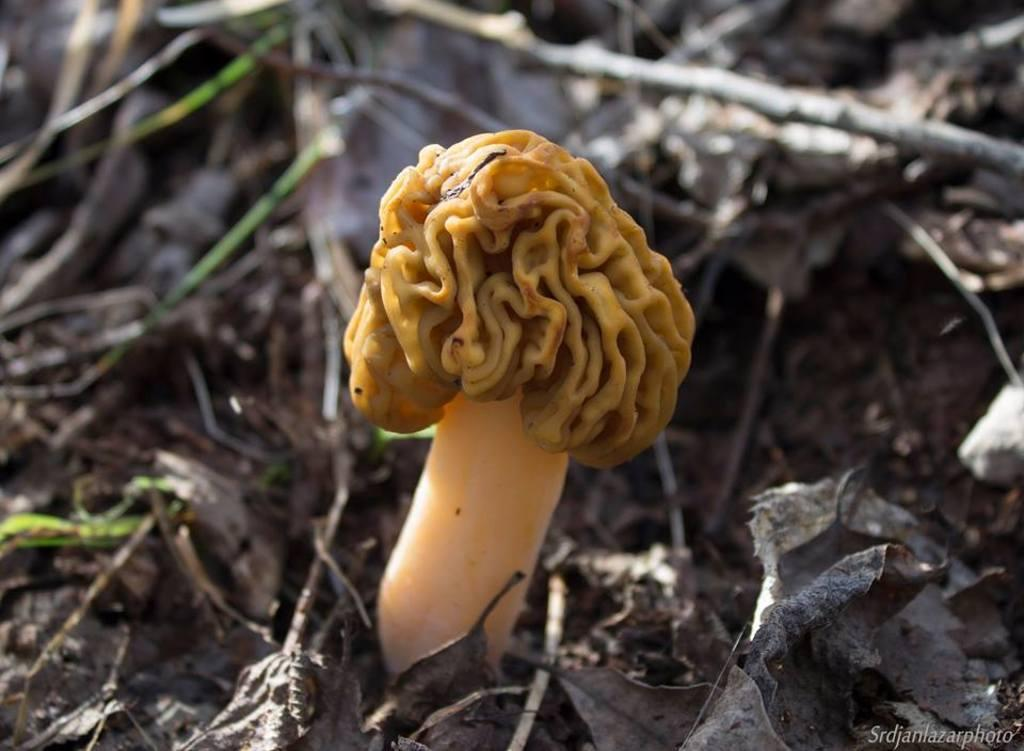What type of organism can be seen on the ground in the image? There is a fungi on the ground in the image. What else can be seen around the fungi? There are dried stems around the fungi. What other natural elements are present on the ground in the image? There are dried leaves on the ground in the image. Where is the text located in the image? The text is in the bottom right corner of the image. How many legs can be seen supporting the roof in the image? There are no legs or roof present in the image; it features a fungi, dried stems, dried leaves, and text. What type of band is playing in the background of the image? There is no band present in the image; it features a fungi, dried stems, dried leaves, and text. 